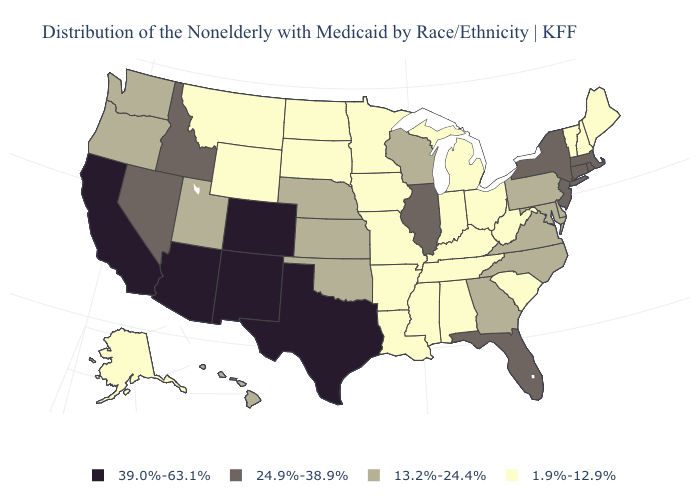Does Arkansas have the lowest value in the South?
Keep it brief. Yes. Name the states that have a value in the range 39.0%-63.1%?
Keep it brief. Arizona, California, Colorado, New Mexico, Texas. Does Alaska have the highest value in the West?
Write a very short answer. No. What is the value of Oklahoma?
Quick response, please. 13.2%-24.4%. What is the value of Washington?
Quick response, please. 13.2%-24.4%. Name the states that have a value in the range 13.2%-24.4%?
Keep it brief. Delaware, Georgia, Hawaii, Kansas, Maryland, Nebraska, North Carolina, Oklahoma, Oregon, Pennsylvania, Utah, Virginia, Washington, Wisconsin. Name the states that have a value in the range 24.9%-38.9%?
Concise answer only. Connecticut, Florida, Idaho, Illinois, Massachusetts, Nevada, New Jersey, New York, Rhode Island. What is the value of North Dakota?
Answer briefly. 1.9%-12.9%. Among the states that border Rhode Island , which have the lowest value?
Give a very brief answer. Connecticut, Massachusetts. Which states have the highest value in the USA?
Give a very brief answer. Arizona, California, Colorado, New Mexico, Texas. What is the value of Idaho?
Answer briefly. 24.9%-38.9%. Name the states that have a value in the range 13.2%-24.4%?
Quick response, please. Delaware, Georgia, Hawaii, Kansas, Maryland, Nebraska, North Carolina, Oklahoma, Oregon, Pennsylvania, Utah, Virginia, Washington, Wisconsin. Name the states that have a value in the range 13.2%-24.4%?
Be succinct. Delaware, Georgia, Hawaii, Kansas, Maryland, Nebraska, North Carolina, Oklahoma, Oregon, Pennsylvania, Utah, Virginia, Washington, Wisconsin. Does the first symbol in the legend represent the smallest category?
Answer briefly. No. What is the value of New Hampshire?
Write a very short answer. 1.9%-12.9%. 